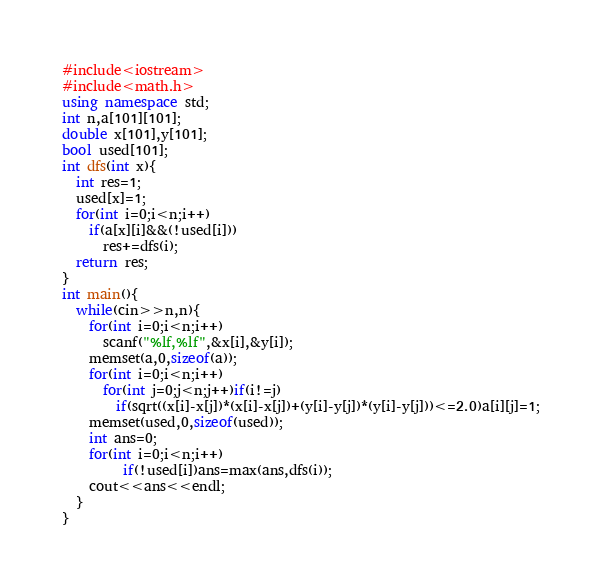Convert code to text. <code><loc_0><loc_0><loc_500><loc_500><_C++_>#include<iostream>
#include<math.h>
using namespace std;
int n,a[101][101];
double x[101],y[101];
bool used[101];
int dfs(int x){
  int res=1;
  used[x]=1;
  for(int i=0;i<n;i++)
    if(a[x][i]&&(!used[i]))
      res+=dfs(i);
  return res;
}
int main(){
  while(cin>>n,n){
    for(int i=0;i<n;i++)
      scanf("%lf,%lf",&x[i],&y[i]);
    memset(a,0,sizeof(a));
    for(int i=0;i<n;i++)
      for(int j=0;j<n;j++)if(i!=j)
        if(sqrt((x[i]-x[j])*(x[i]-x[j])+(y[i]-y[j])*(y[i]-y[j]))<=2.0)a[i][j]=1;
    memset(used,0,sizeof(used));
    int ans=0;
    for(int i=0;i<n;i++)
         if(!used[i])ans=max(ans,dfs(i));
    cout<<ans<<endl;
  }
}</code> 